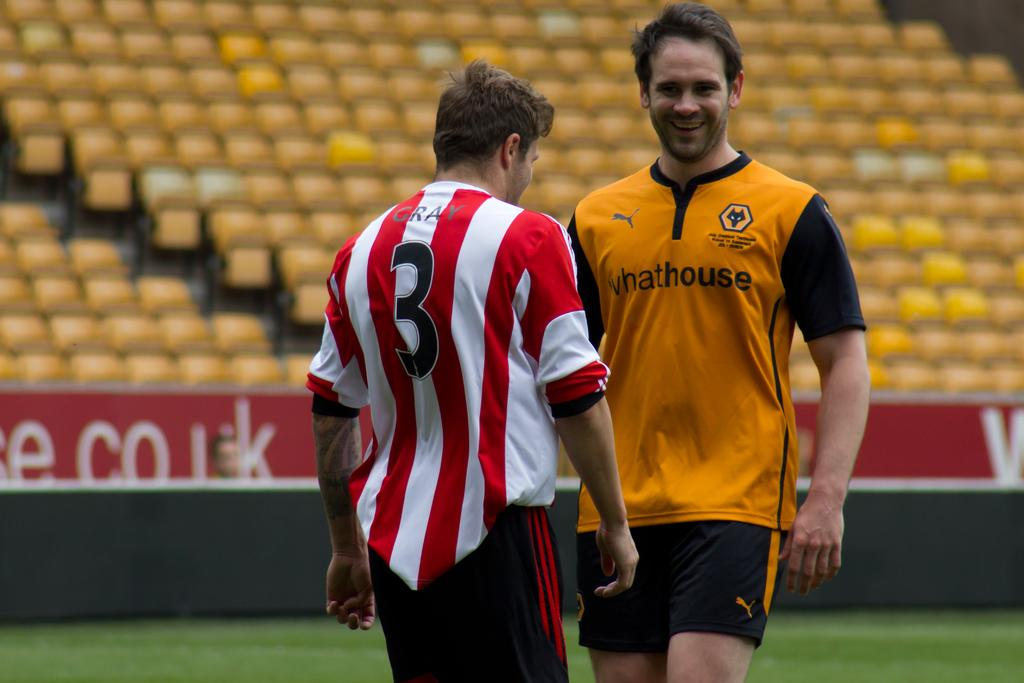<image>
Describe the image concisely. A player with number 3 on his back standing next to a player with an orange shirt 